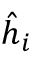<formula> <loc_0><loc_0><loc_500><loc_500>\hat { h } _ { i }</formula> 